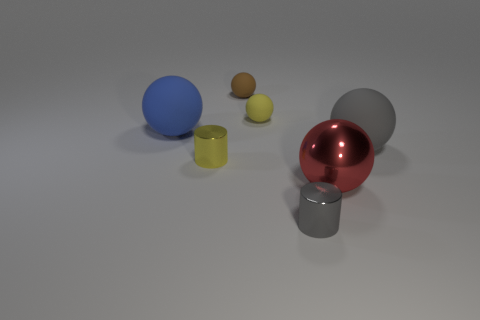What is the small brown thing made of?
Your answer should be very brief. Rubber. Do the brown sphere that is behind the tiny yellow matte ball and the gray cylinder have the same material?
Ensure brevity in your answer.  No. How big is the metal cylinder behind the tiny metallic cylinder that is to the right of the small yellow shiny cylinder?
Provide a short and direct response. Small. What size is the ball in front of the big rubber sphere to the right of the small rubber thing on the right side of the tiny brown object?
Offer a terse response. Large. Does the small metal object that is to the left of the tiny brown matte object have the same shape as the small shiny thing on the right side of the brown rubber thing?
Keep it short and to the point. Yes. How many other objects are there of the same color as the metal ball?
Provide a succinct answer. 0. Is the size of the metallic cylinder behind the red metal ball the same as the gray metallic object?
Offer a very short reply. Yes. Is the tiny yellow thing that is in front of the blue rubber ball made of the same material as the large ball behind the gray matte sphere?
Give a very brief answer. No. Are there any green matte cylinders that have the same size as the red metallic sphere?
Offer a terse response. No. What shape is the small yellow object that is in front of the big matte ball left of the large red metallic sphere to the right of the tiny brown object?
Ensure brevity in your answer.  Cylinder. 